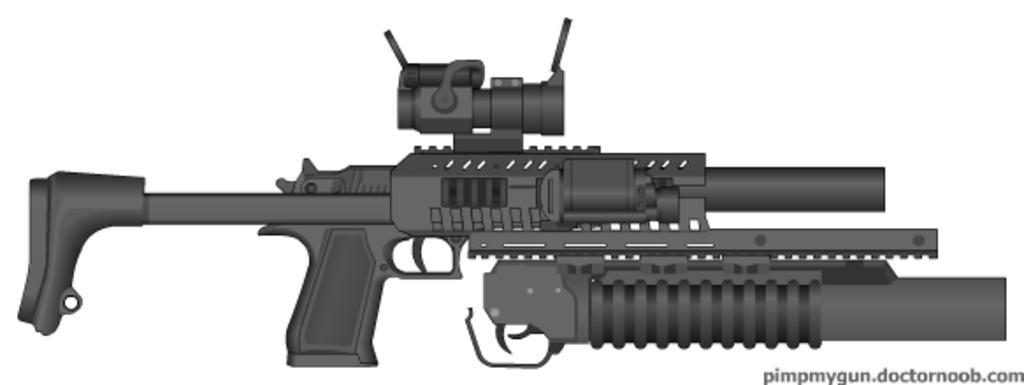Describe this image in one or two sentences. In this image I can see the gun in black color and I can see the white color background. 